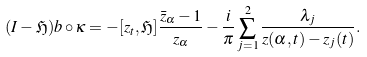Convert formula to latex. <formula><loc_0><loc_0><loc_500><loc_500>( I - \mathfrak { H } ) b \circ \kappa = - [ z _ { t } , \mathfrak { H } ] \frac { \bar { z } _ { \alpha } - 1 } { z _ { \alpha } } - \frac { i } { \pi } \sum _ { j = 1 } ^ { 2 } \frac { \lambda _ { j } } { z ( \alpha , t ) - z _ { j } ( t ) } .</formula> 